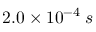<formula> <loc_0><loc_0><loc_500><loc_500>2 . 0 \times 1 0 ^ { - 4 } \, s</formula> 